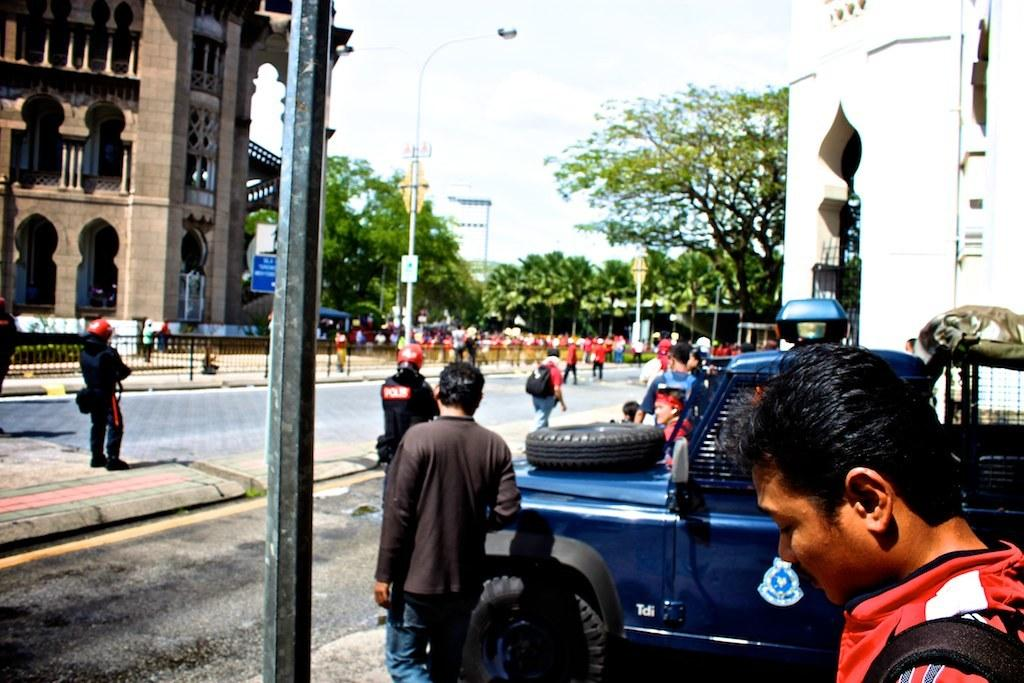What type of structures can be seen in the image? There are buildings in the image. What other natural elements are present in the image? There are trees in the image. Are there any people in the image? Yes, there are people standing and walking in the image. What is on the road in the image? There is a vehicle on the road in the image. Can you read any text in the image? Yes, there is a board with text in the image. How would you describe the weather in the image? The sky is cloudy in the image. What type of cake is being served at the event in the image? There is no event or cake present in the image. Can you describe the loaf of bread being used by the people in the image? There is no loaf of bread present in the image. 